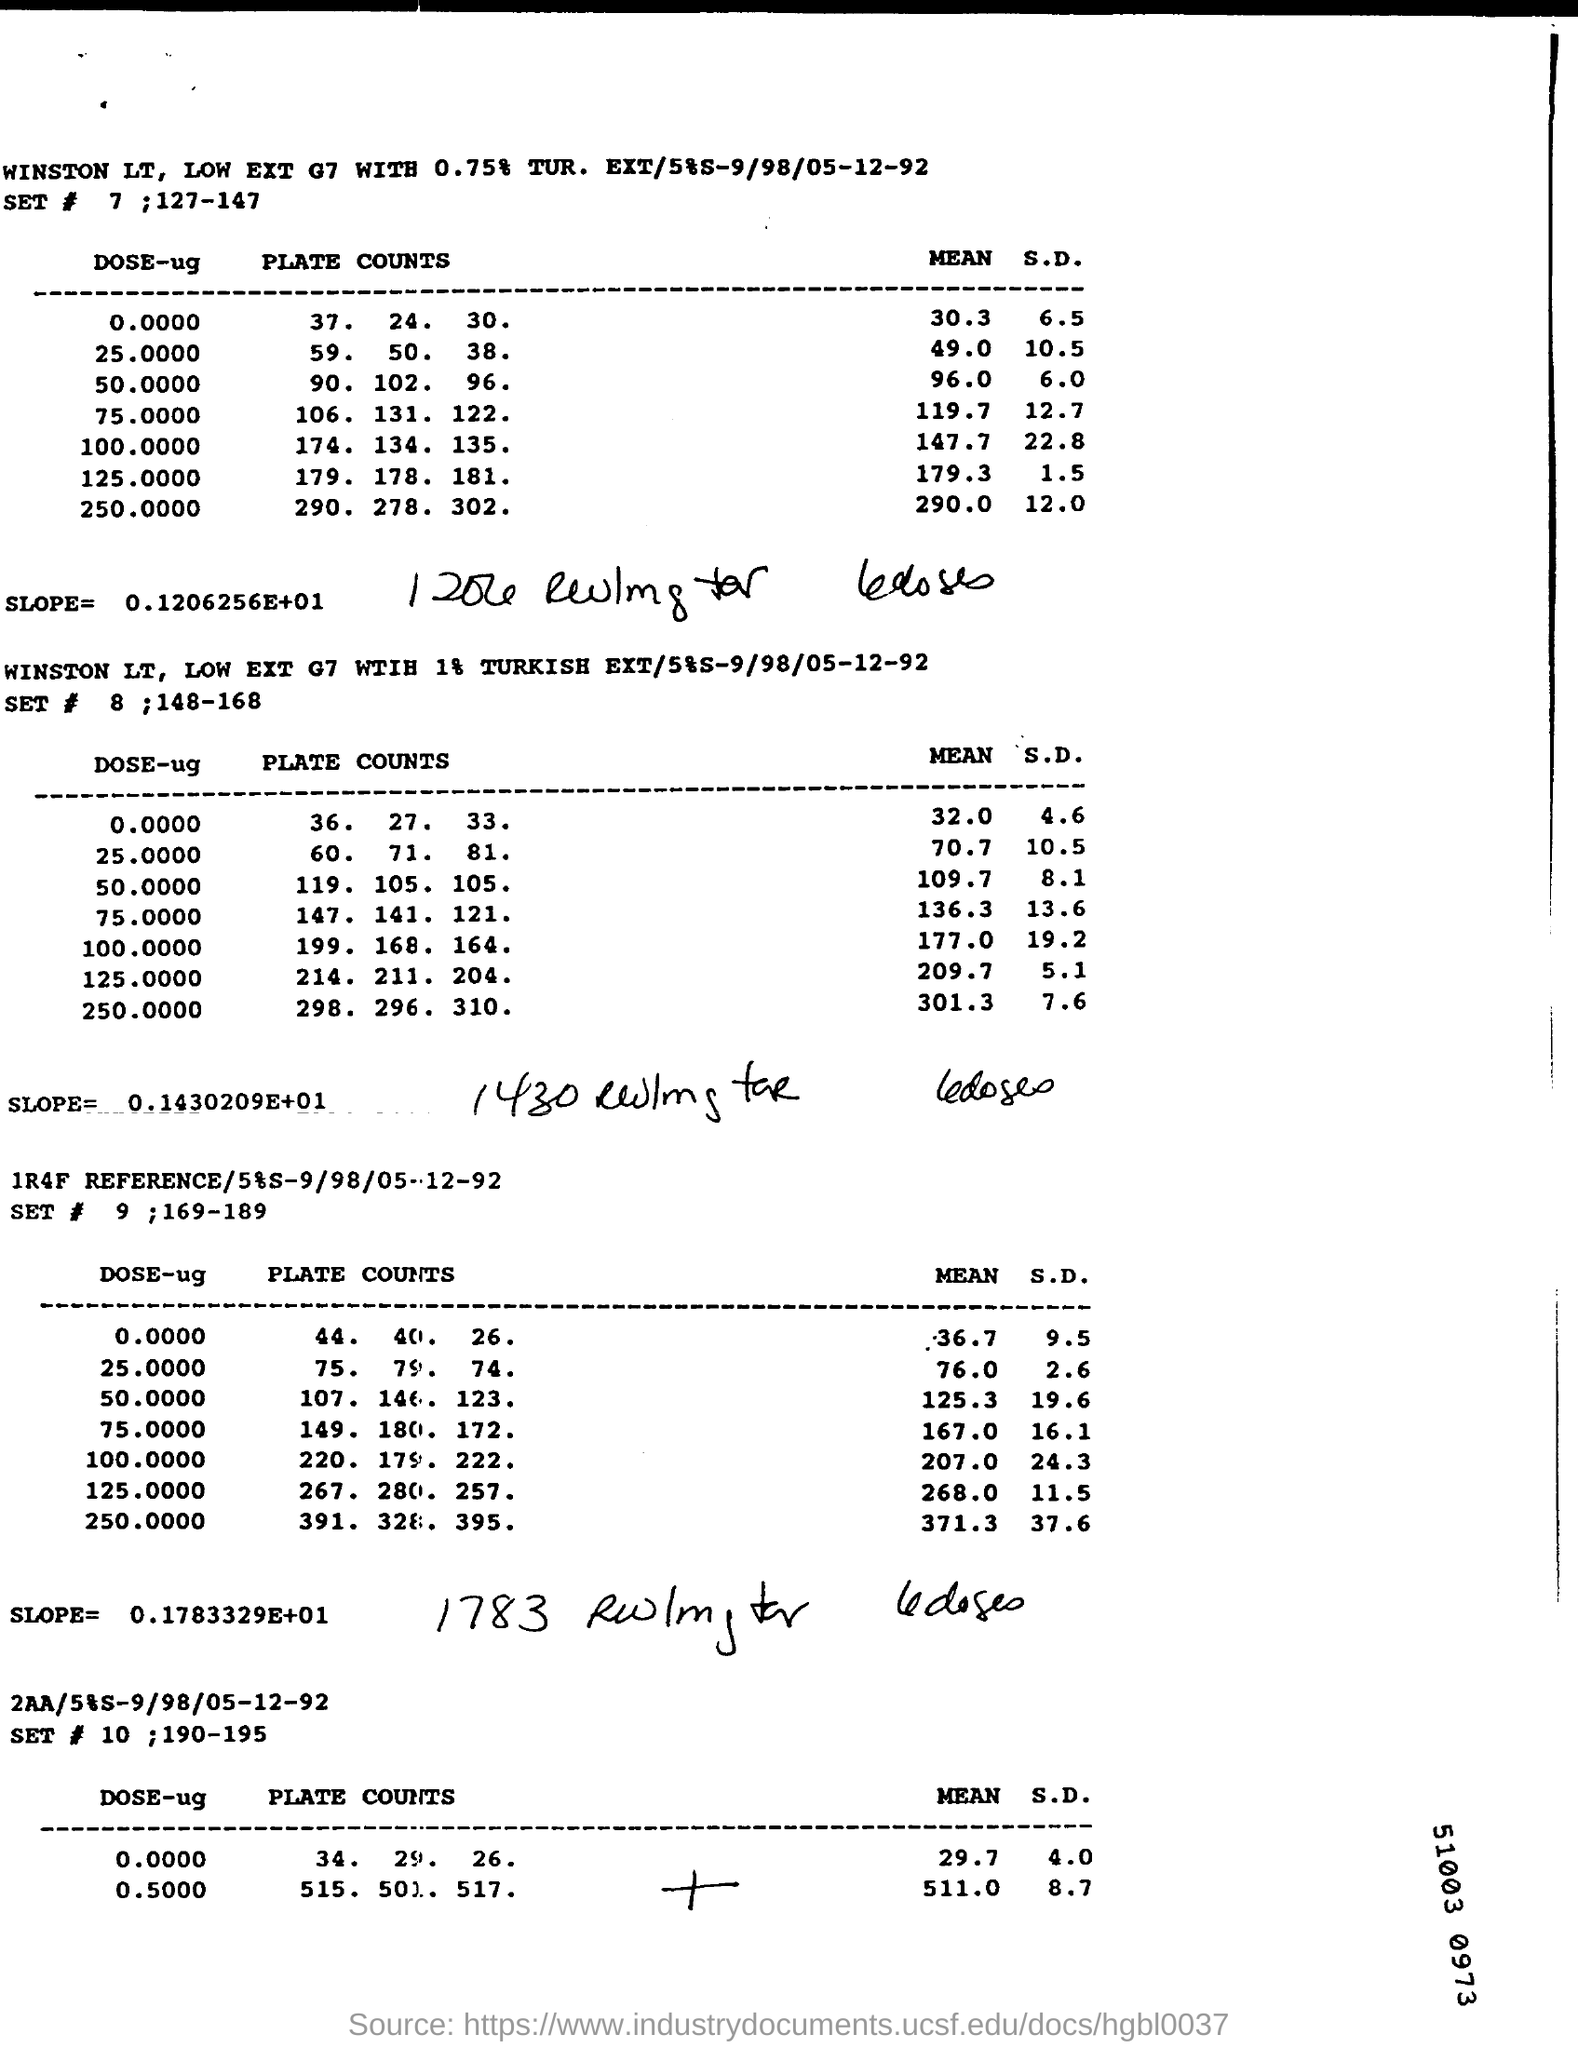What is the "PLATE COUNTS" for "DOSE" of 0.0000 mentioned in the first table?
Provide a short and direct response. 37.  24.  30. What is the title of first table?
Give a very brief answer. WINSTON LT, LOW EXT G7 WITH 0.75% TUR.  EXT/5%S-9/98/05-12-92. What is the heading given to the second  table?
Your response must be concise. WINSTON LT,  LOW EXT G7 WITH 1% TURKISH EXT/5%S-9/98/05-12-92. What is the heading given to third table?
Your answer should be compact. 1R4F REFERENCE/5%S-9/98/05-12-92. What is the "SLOPE" of   first table?
Ensure brevity in your answer.  0.1206256E+01. What is the "SLOPE" of third table?
Your answer should be very brief. 0.1783329E+01. What is the "SLOPE" of second table?
Keep it short and to the point. 0.1430209E+01. What is the "SET #" number given to the first table?
Make the answer very short. 7 ; 127-147. What is the "SET #" number given to the second table?
Your response must be concise. 8 ;148-168. What is the "SET #" number given to the third table?
Ensure brevity in your answer.  9 ;169-189. What is the "SET #" number given to the fourth table?
Offer a very short reply. 10 ;190-195. 